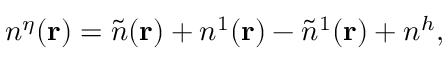Convert formula to latex. <formula><loc_0><loc_0><loc_500><loc_500>n ^ { \eta } ( { r } ) = \tilde { n } ( { r } ) + n ^ { 1 } ( { r } ) - \tilde { n } ^ { 1 } ( { r } ) + n ^ { h } ,</formula> 